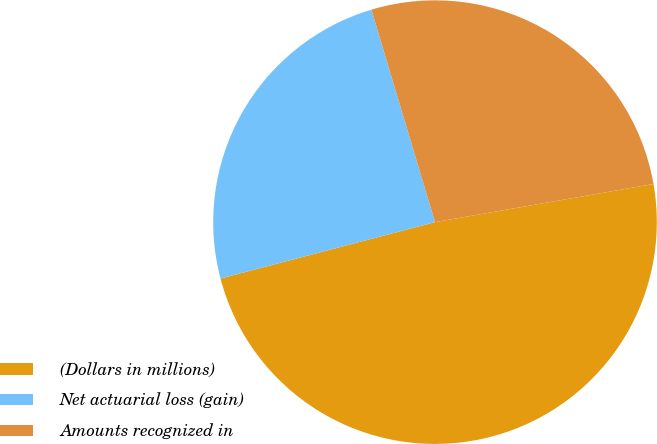Convert chart. <chart><loc_0><loc_0><loc_500><loc_500><pie_chart><fcel>(Dollars in millions)<fcel>Net actuarial loss (gain)<fcel>Amounts recognized in<nl><fcel>48.66%<fcel>24.46%<fcel>26.88%<nl></chart> 